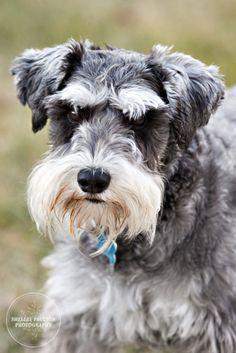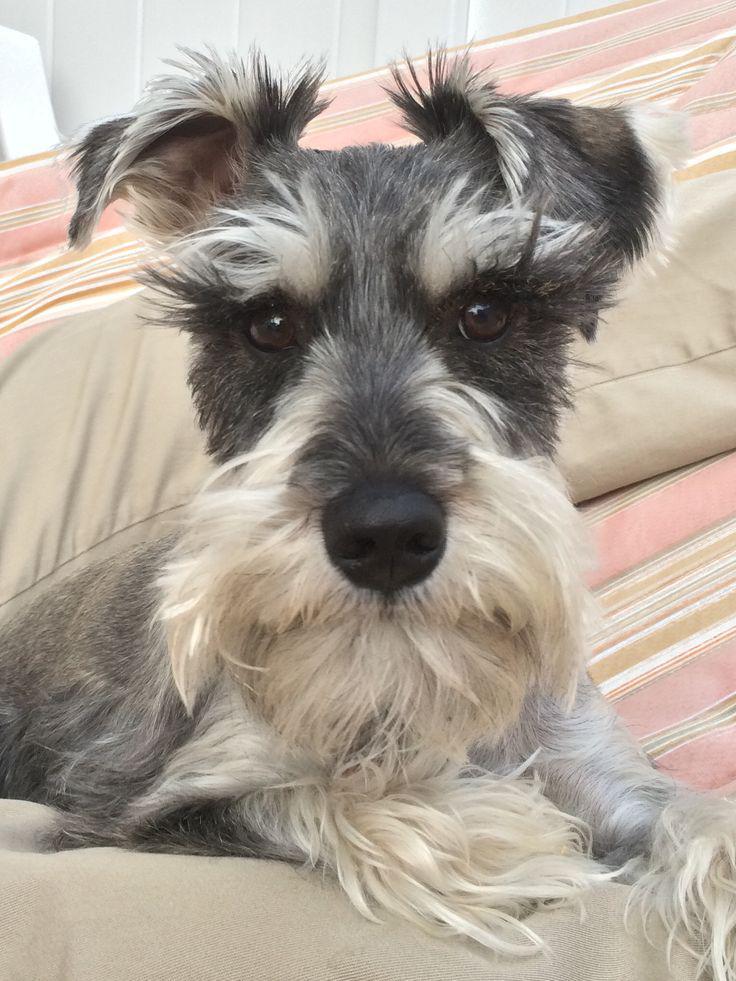The first image is the image on the left, the second image is the image on the right. Considering the images on both sides, is "In one of the images a dog can be seen wearing a collar." valid? Answer yes or no. Yes. The first image is the image on the left, the second image is the image on the right. Evaluate the accuracy of this statement regarding the images: "All dogs face directly forward, and all dogs have 'beards and mustaches' that are a different color from the rest of the fur on their faces.". Is it true? Answer yes or no. Yes. 